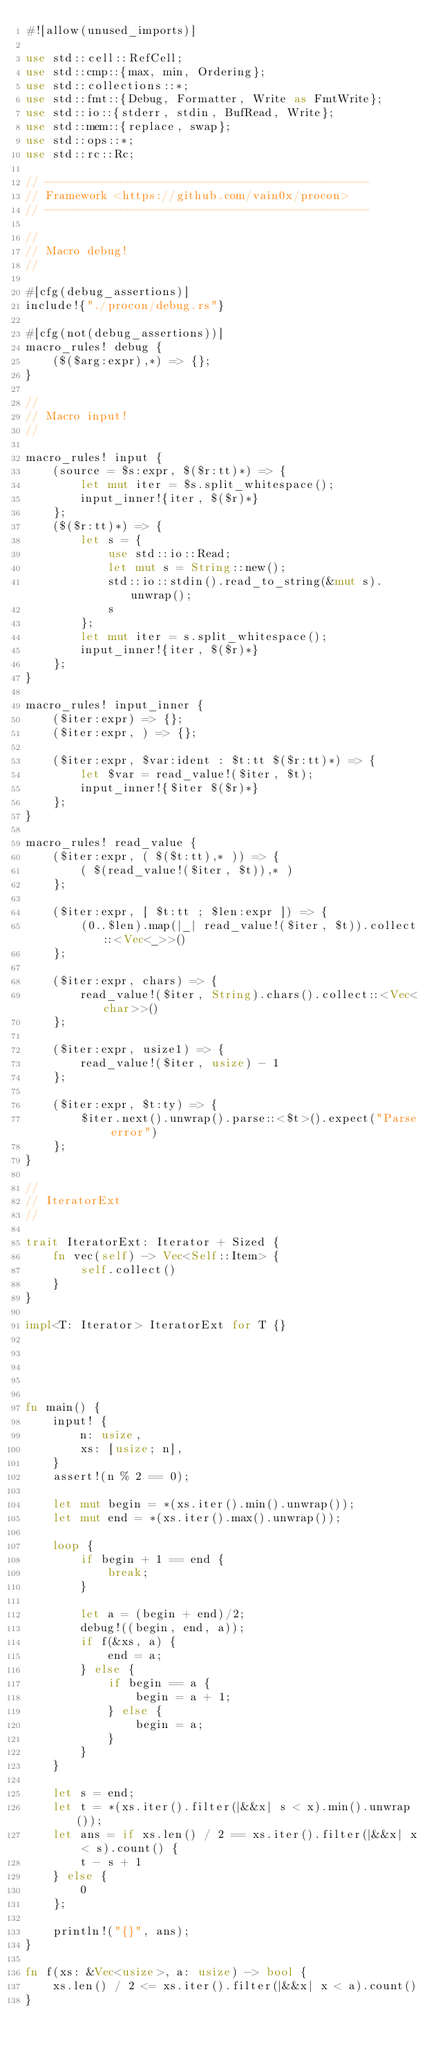Convert code to text. <code><loc_0><loc_0><loc_500><loc_500><_Rust_>#![allow(unused_imports)]

use std::cell::RefCell;
use std::cmp::{max, min, Ordering};
use std::collections::*;
use std::fmt::{Debug, Formatter, Write as FmtWrite};
use std::io::{stderr, stdin, BufRead, Write};
use std::mem::{replace, swap};
use std::ops::*;
use std::rc::Rc;

// -----------------------------------------------
// Framework <https://github.com/vain0x/procon>
// -----------------------------------------------

//
// Macro debug!
//

#[cfg(debug_assertions)]
include!{"./procon/debug.rs"}

#[cfg(not(debug_assertions))]
macro_rules! debug {
    ($($arg:expr),*) => {};
}

//
// Macro input!
//

macro_rules! input {
    (source = $s:expr, $($r:tt)*) => {
        let mut iter = $s.split_whitespace();
        input_inner!{iter, $($r)*}
    };
    ($($r:tt)*) => {
        let s = {
            use std::io::Read;
            let mut s = String::new();
            std::io::stdin().read_to_string(&mut s).unwrap();
            s
        };
        let mut iter = s.split_whitespace();
        input_inner!{iter, $($r)*}
    };
}

macro_rules! input_inner {
    ($iter:expr) => {};
    ($iter:expr, ) => {};

    ($iter:expr, $var:ident : $t:tt $($r:tt)*) => {
        let $var = read_value!($iter, $t);
        input_inner!{$iter $($r)*}
    };
}

macro_rules! read_value {
    ($iter:expr, ( $($t:tt),* )) => {
        ( $(read_value!($iter, $t)),* )
    };

    ($iter:expr, [ $t:tt ; $len:expr ]) => {
        (0..$len).map(|_| read_value!($iter, $t)).collect::<Vec<_>>()
    };

    ($iter:expr, chars) => {
        read_value!($iter, String).chars().collect::<Vec<char>>()
    };

    ($iter:expr, usize1) => {
        read_value!($iter, usize) - 1
    };

    ($iter:expr, $t:ty) => {
        $iter.next().unwrap().parse::<$t>().expect("Parse error")
    };
}

//
// IteratorExt
//

trait IteratorExt: Iterator + Sized {
    fn vec(self) -> Vec<Self::Item> {
        self.collect()
    }
}

impl<T: Iterator> IteratorExt for T {}





fn main() {
    input! {
        n: usize,
        xs: [usize; n],
    }
    assert!(n % 2 == 0);

    let mut begin = *(xs.iter().min().unwrap());
    let mut end = *(xs.iter().max().unwrap());

    loop {
        if begin + 1 == end {
            break;
        }

        let a = (begin + end)/2;
        debug!((begin, end, a));
        if f(&xs, a) {
            end = a;
        } else {
            if begin == a {
                begin = a + 1;
            } else {
                begin = a;
            }
        }
    }

    let s = end;
    let t = *(xs.iter().filter(|&&x| s < x).min().unwrap());
    let ans = if xs.len() / 2 == xs.iter().filter(|&&x| x < s).count() {
        t - s + 1
    } else {
        0
    };

    println!("{}", ans);
}

fn f(xs: &Vec<usize>, a: usize) -> bool {
    xs.len() / 2 <= xs.iter().filter(|&&x| x < a).count()
}
</code> 